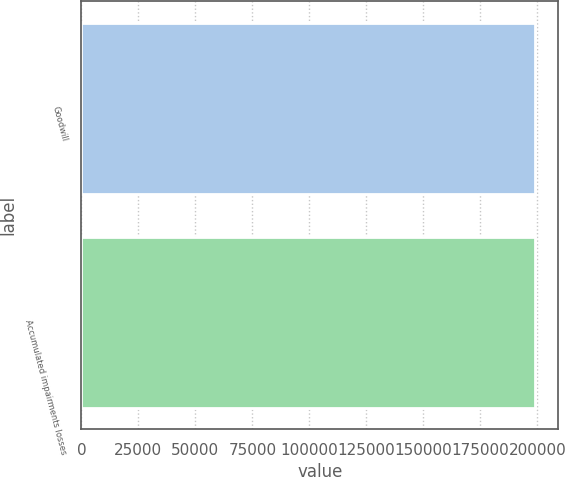Convert chart to OTSL. <chart><loc_0><loc_0><loc_500><loc_500><bar_chart><fcel>Goodwill<fcel>Accumulated impairments losses<nl><fcel>199132<fcel>199132<nl></chart> 